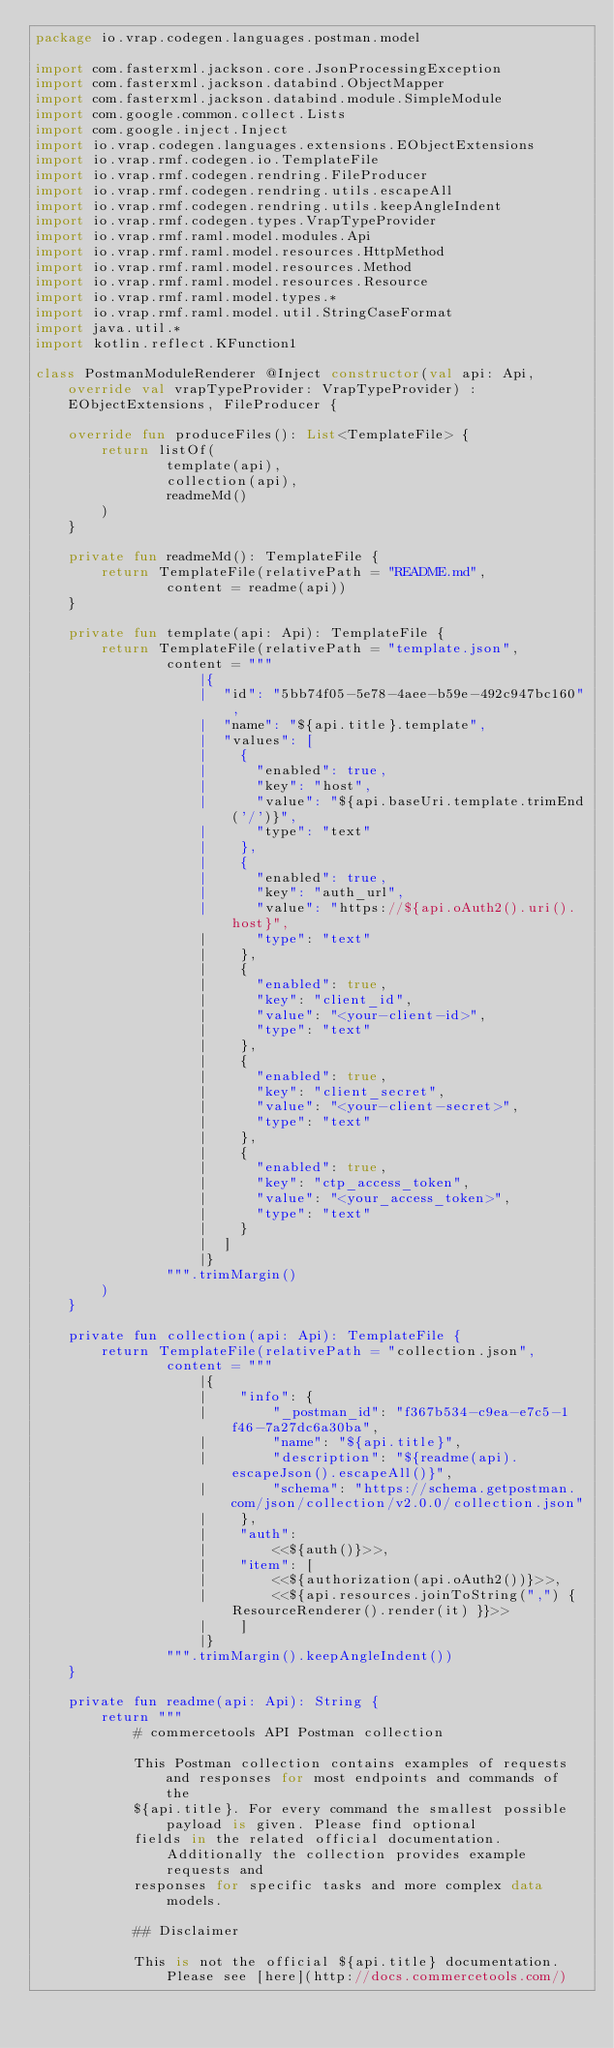Convert code to text. <code><loc_0><loc_0><loc_500><loc_500><_Kotlin_>package io.vrap.codegen.languages.postman.model

import com.fasterxml.jackson.core.JsonProcessingException
import com.fasterxml.jackson.databind.ObjectMapper
import com.fasterxml.jackson.databind.module.SimpleModule
import com.google.common.collect.Lists
import com.google.inject.Inject
import io.vrap.codegen.languages.extensions.EObjectExtensions
import io.vrap.rmf.codegen.io.TemplateFile
import io.vrap.rmf.codegen.rendring.FileProducer
import io.vrap.rmf.codegen.rendring.utils.escapeAll
import io.vrap.rmf.codegen.rendring.utils.keepAngleIndent
import io.vrap.rmf.codegen.types.VrapTypeProvider
import io.vrap.rmf.raml.model.modules.Api
import io.vrap.rmf.raml.model.resources.HttpMethod
import io.vrap.rmf.raml.model.resources.Method
import io.vrap.rmf.raml.model.resources.Resource
import io.vrap.rmf.raml.model.types.*
import io.vrap.rmf.raml.model.util.StringCaseFormat
import java.util.*
import kotlin.reflect.KFunction1

class PostmanModuleRenderer @Inject constructor(val api: Api, override val vrapTypeProvider: VrapTypeProvider) : EObjectExtensions, FileProducer {

    override fun produceFiles(): List<TemplateFile> {
        return listOf(
                template(api),
                collection(api),
                readmeMd()
        )
    }

    private fun readmeMd(): TemplateFile {
        return TemplateFile(relativePath = "README.md",
                content = readme(api))
    }

    private fun template(api: Api): TemplateFile {
        return TemplateFile(relativePath = "template.json",
                content = """
                    |{
                    |  "id": "5bb74f05-5e78-4aee-b59e-492c947bc160",
                    |  "name": "${api.title}.template",
                    |  "values": [
                    |    {
                    |      "enabled": true,
                    |      "key": "host",
                    |      "value": "${api.baseUri.template.trimEnd('/')}",
                    |      "type": "text"
                    |    },
                    |    {
                    |      "enabled": true,
                    |      "key": "auth_url",
                    |      "value": "https://${api.oAuth2().uri().host}",
                    |      "type": "text"
                    |    },
                    |    {
                    |      "enabled": true,
                    |      "key": "client_id",
                    |      "value": "<your-client-id>",
                    |      "type": "text"
                    |    },
                    |    {
                    |      "enabled": true,
                    |      "key": "client_secret",
                    |      "value": "<your-client-secret>",
                    |      "type": "text"
                    |    },
                    |    {
                    |      "enabled": true,
                    |      "key": "ctp_access_token",
                    |      "value": "<your_access_token>",
                    |      "type": "text"
                    |    }
                    |  ]
                    |}
                """.trimMargin()
        )
    }

    private fun collection(api: Api): TemplateFile {
        return TemplateFile(relativePath = "collection.json",
                content = """
                    |{
                    |    "info": {
                    |        "_postman_id": "f367b534-c9ea-e7c5-1f46-7a27dc6a30ba",
                    |        "name": "${api.title}",
                    |        "description": "${readme(api).escapeJson().escapeAll()}",
                    |        "schema": "https://schema.getpostman.com/json/collection/v2.0.0/collection.json"
                    |    },
                    |    "auth":
                    |        <<${auth()}>>,
                    |    "item": [
                    |        <<${authorization(api.oAuth2())}>>,
                    |        <<${api.resources.joinToString(",") { ResourceRenderer().render(it) }}>>
                    |    ]
                    |}
                """.trimMargin().keepAngleIndent())
    }

    private fun readme(api: Api): String {
        return """
            # commercetools API Postman collection

            This Postman collection contains examples of requests and responses for most endpoints and commands of the
            ${api.title}. For every command the smallest possible payload is given. Please find optional
            fields in the related official documentation. Additionally the collection provides example requests and
            responses for specific tasks and more complex data models.

            ## Disclaimer

            This is not the official ${api.title} documentation. Please see [here](http://docs.commercetools.com/)</code> 